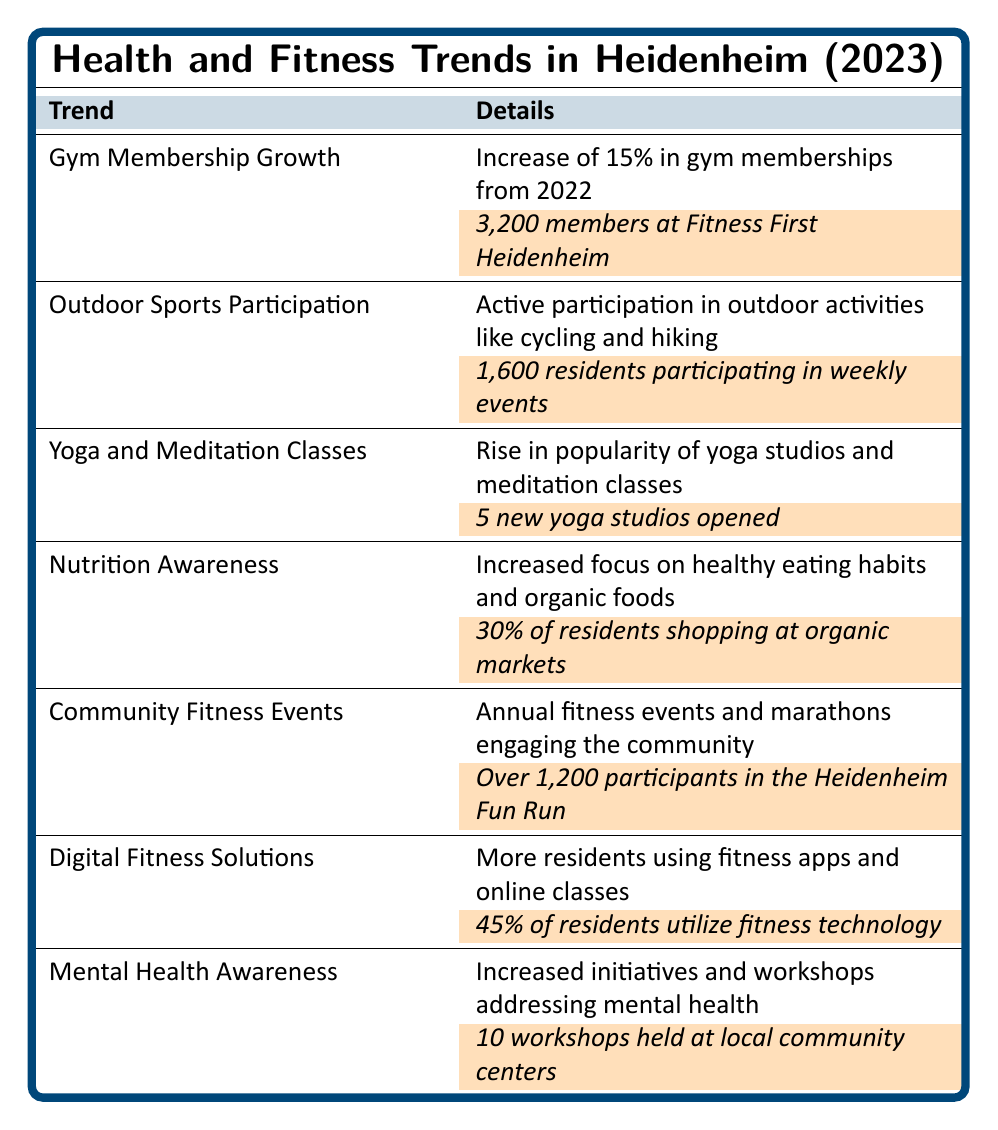What is the percentage increase in gym memberships from 2022? The table states there is a 15% increase in gym memberships from 2022.
Answer: 15% How many residents in Heidenheim participate in weekly outdoor sports events? The highlighted value in the table states that there are 1,600 residents participating in weekly events.
Answer: 1,600 residents How many new yoga studios opened in Heidenheim in 2023? The table highlights that 5 new yoga studios opened in Heidenheim.
Answer: 5 studios What percentage of residents shop at organic markets? According to the table, 30% of residents are shopping at organic markets.
Answer: 30% Did the number of participants in the Heidenheim Fun Run exceed 1,000? The table states that there were over 1,200 participants in the Heidenheim Fun Run, which exceeds 1,000.
Answer: Yes How many workshops addressing mental health were held? The table indicates that there were 10 workshops held at local community centers.
Answer: 10 workshops What is the total number of participants across the highlighted fitness trends (gym memberships, outdoor sports, community fitness events)? We add the highlighted values: 3,200 (gym memberships) + 1,600 (outdoor sports) + 1,200 (Fun Run) = 6,000 participants total across these trends.
Answer: 6,000 participants How does the percentage of residents utilizing fitness technology compare to those participating in outdoor sports events? The table shows that 45% of residents utilize fitness technology, while 1,600 residents participate in outdoor sports. In strict numerical comparison, we can't convert residents directly to a percentage of the population, but we can infer that a significant number still engage in outdoor sports.
Answer: Not directly comparable What is the difference between the number of gym members and the number of outdoor sports participants? The number of gym members is 3,200, and outdoor sports participants are 1,600. The difference is 3,200 - 1,600 = 1,600.
Answer: 1,600 Are there more yoga studios opened than workshops focused on mental health? There are 5 new yoga studios and 10 workshops. Since 5 is less than 10, there are not more yoga studios than workshops.
Answer: No 